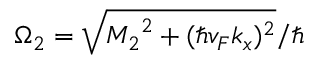Convert formula to latex. <formula><loc_0><loc_0><loc_500><loc_500>\Omega _ { 2 } = \sqrt { { M _ { 2 } } ^ { 2 } + ( \hbar { v } _ { F } k _ { x } ) ^ { 2 } } / \hbar</formula> 